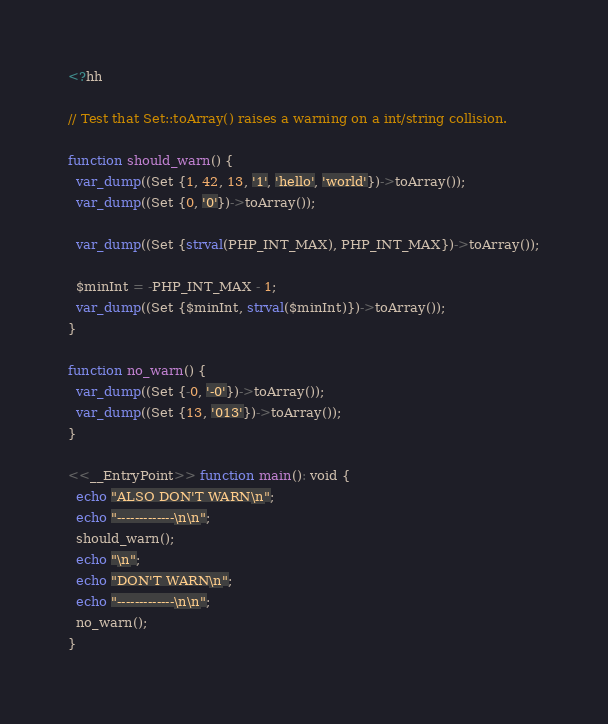Convert code to text. <code><loc_0><loc_0><loc_500><loc_500><_PHP_><?hh

// Test that Set::toArray() raises a warning on a int/string collision.

function should_warn() {
  var_dump((Set {1, 42, 13, '1', 'hello', 'world'})->toArray());
  var_dump((Set {0, '0'})->toArray());

  var_dump((Set {strval(PHP_INT_MAX), PHP_INT_MAX})->toArray());

  $minInt = -PHP_INT_MAX - 1;
  var_dump((Set {$minInt, strval($minInt)})->toArray());
}

function no_warn() {
  var_dump((Set {-0, '-0'})->toArray());
  var_dump((Set {13, '013'})->toArray());
}

<<__EntryPoint>> function main(): void {
  echo "ALSO DON'T WARN\n";
  echo "-------------\n\n";
  should_warn();
  echo "\n";
  echo "DON'T WARN\n";
  echo "-------------\n\n";
  no_warn();
}
</code> 